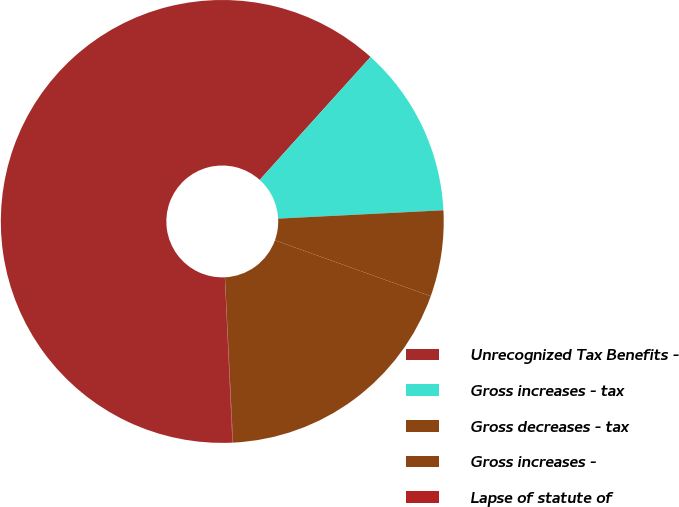Convert chart. <chart><loc_0><loc_0><loc_500><loc_500><pie_chart><fcel>Unrecognized Tax Benefits -<fcel>Gross increases - tax<fcel>Gross decreases - tax<fcel>Gross increases -<fcel>Lapse of statute of<nl><fcel>62.41%<fcel>12.52%<fcel>6.28%<fcel>18.75%<fcel>0.04%<nl></chart> 